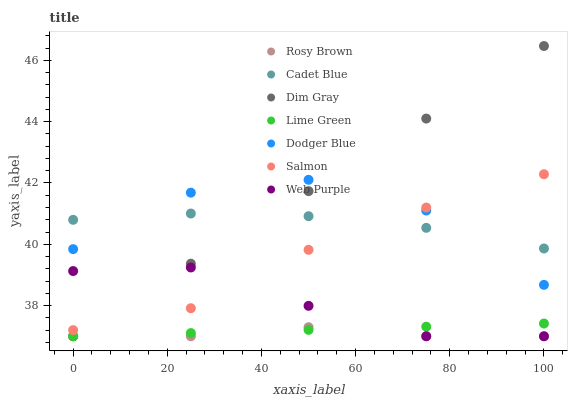Does Rosy Brown have the minimum area under the curve?
Answer yes or no. Yes. Does Dim Gray have the maximum area under the curve?
Answer yes or no. Yes. Does Salmon have the minimum area under the curve?
Answer yes or no. No. Does Salmon have the maximum area under the curve?
Answer yes or no. No. Is Lime Green the smoothest?
Answer yes or no. Yes. Is Dodger Blue the roughest?
Answer yes or no. Yes. Is Rosy Brown the smoothest?
Answer yes or no. No. Is Rosy Brown the roughest?
Answer yes or no. No. Does Rosy Brown have the lowest value?
Answer yes or no. Yes. Does Salmon have the lowest value?
Answer yes or no. No. Does Dim Gray have the highest value?
Answer yes or no. Yes. Does Salmon have the highest value?
Answer yes or no. No. Is Rosy Brown less than Dodger Blue?
Answer yes or no. Yes. Is Cadet Blue greater than Rosy Brown?
Answer yes or no. Yes. Does Dim Gray intersect Rosy Brown?
Answer yes or no. Yes. Is Dim Gray less than Rosy Brown?
Answer yes or no. No. Is Dim Gray greater than Rosy Brown?
Answer yes or no. No. Does Rosy Brown intersect Dodger Blue?
Answer yes or no. No. 